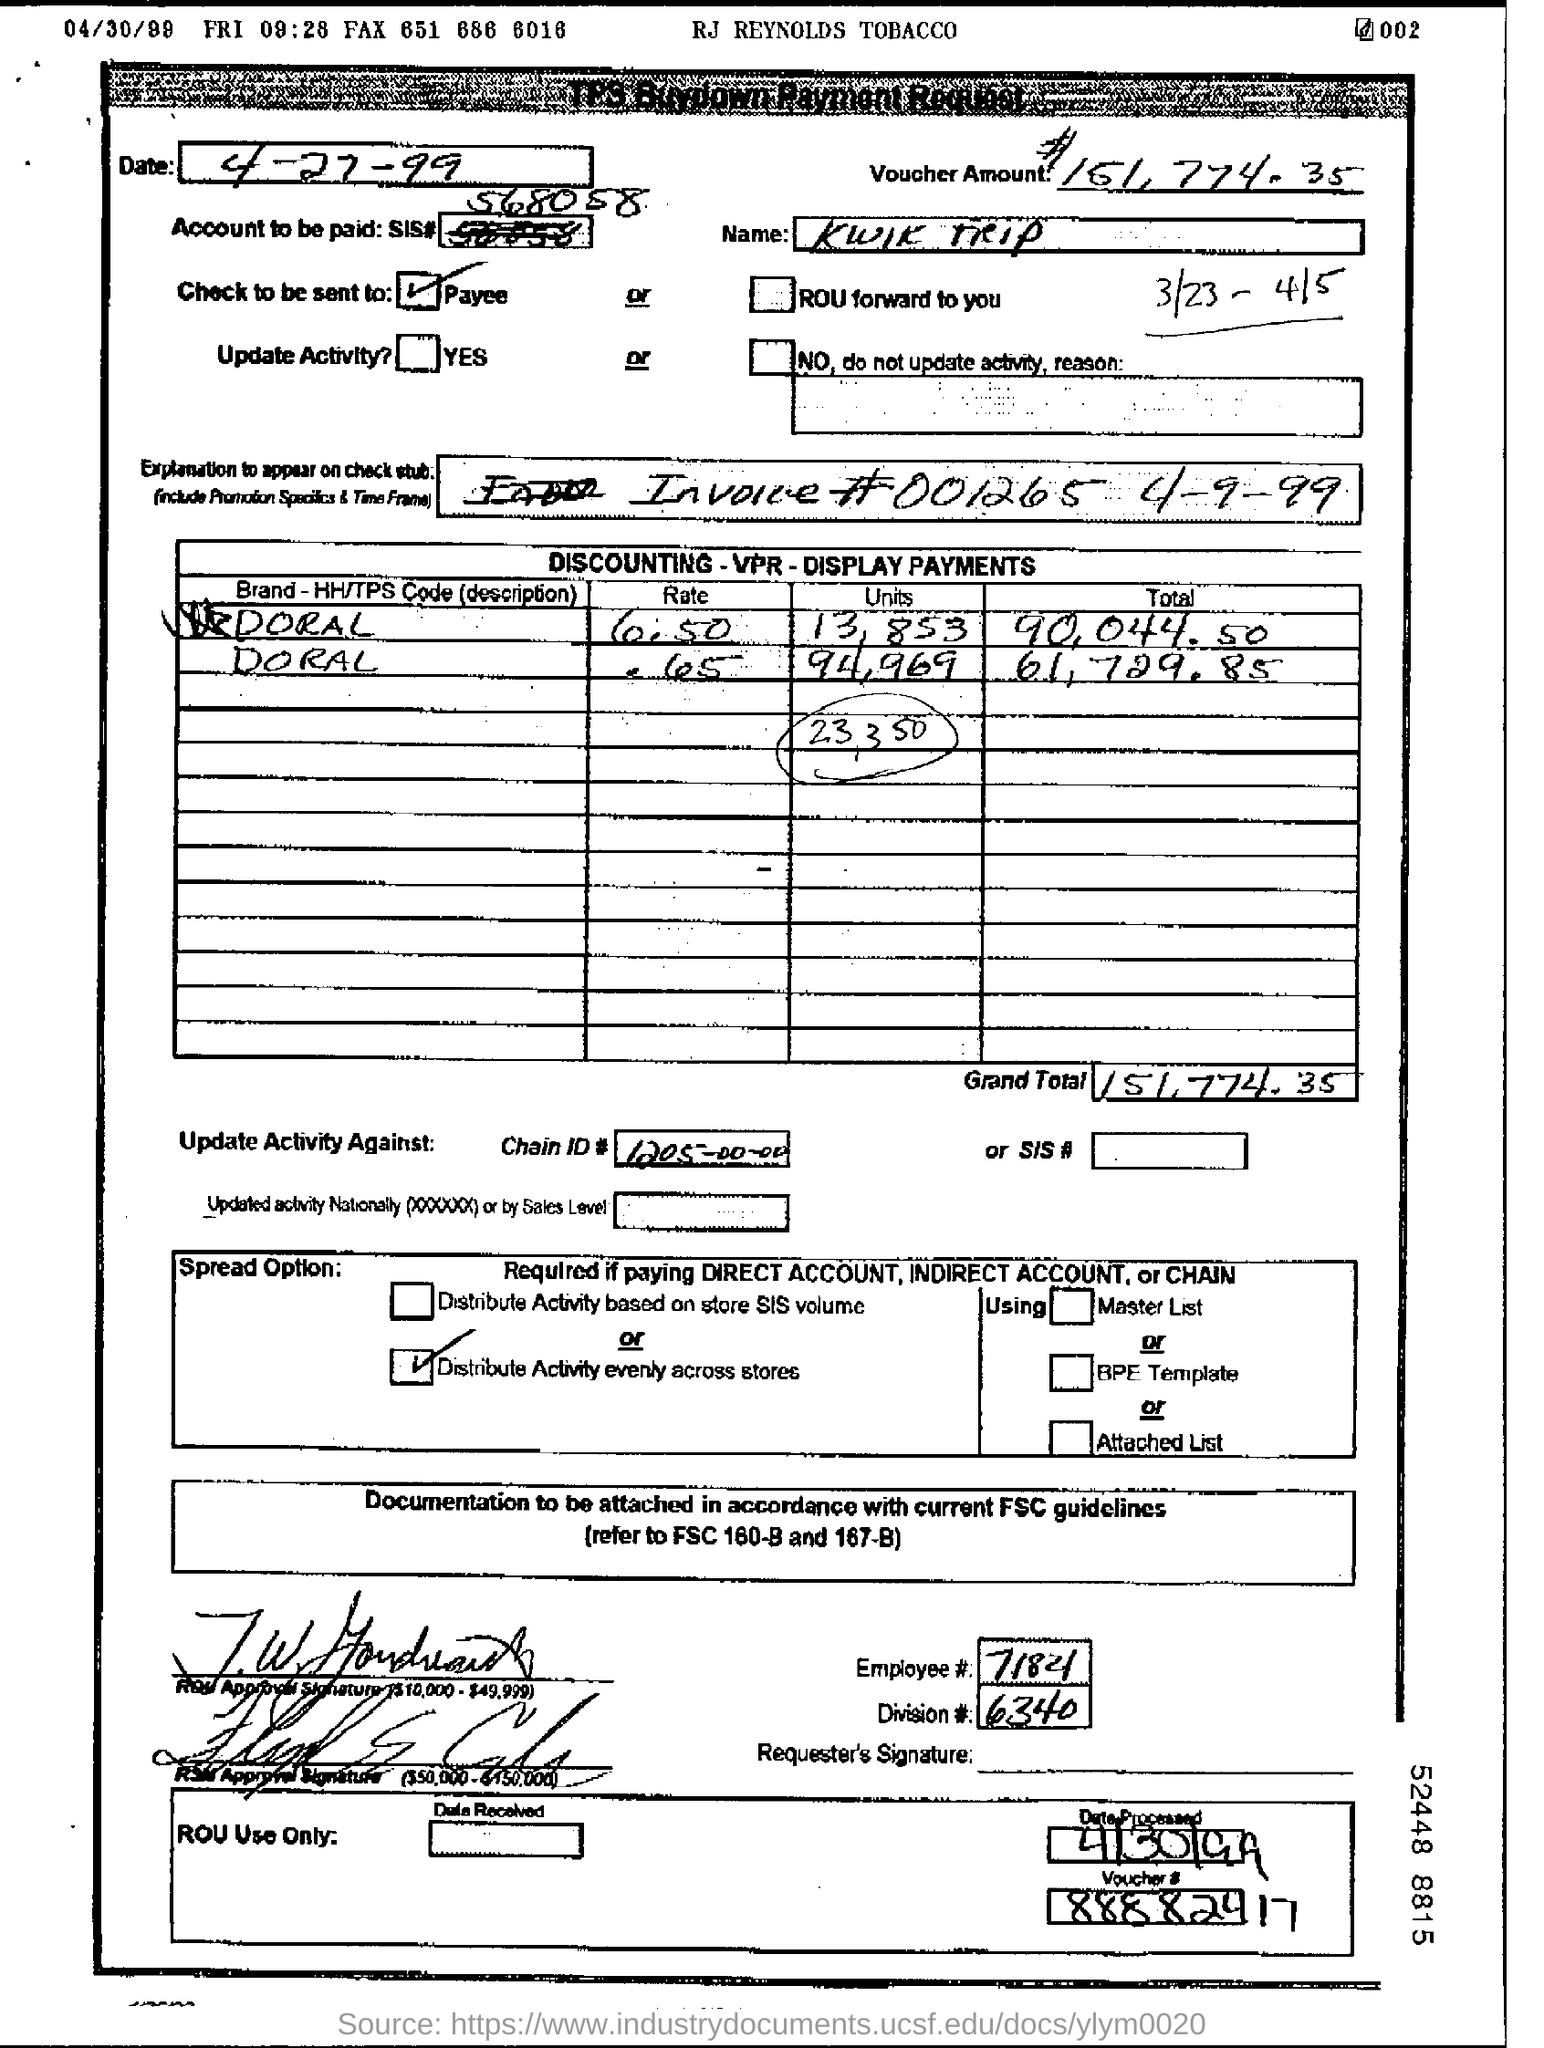Outline some significant characteristics in this image. The division number mentioned in the form is 6340. The employee number provided in the form is 7184... What chain ID number is mentioned in the form? It is 1205-00-00... The voucher amount given in the form is $151,774.35. The invoice number provided in the form is 001265... 